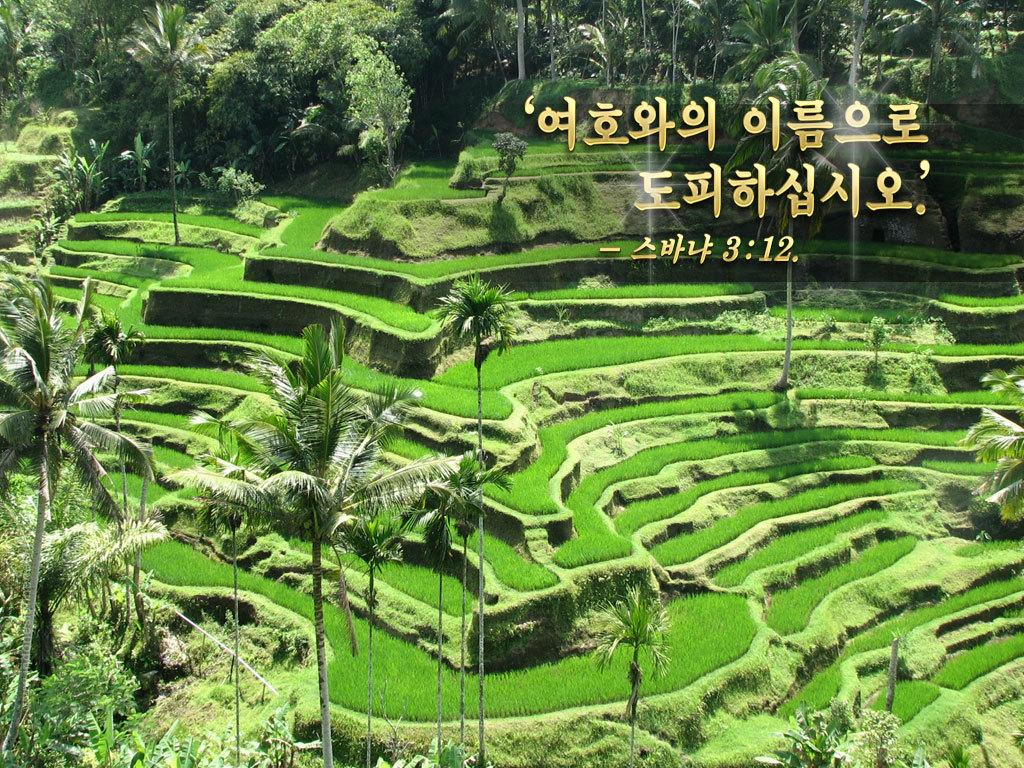What type of vegetation can be seen in the image? There are trees in the image. What type of agricultural land is present in the image? There is a plantation in the image. Where are the trees and plantation located? The trees and plantation are located on a valley. What type of mitten is being worn by the tree in the image? There are no mittens present in the image, as trees do not wear clothing. 